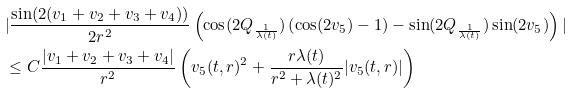<formula> <loc_0><loc_0><loc_500><loc_500>& | \frac { \sin ( 2 ( v _ { 1 } + v _ { 2 } + v _ { 3 } + v _ { 4 } ) ) } { 2 r ^ { 2 } } \left ( \cos ( 2 Q _ { \frac { 1 } { \lambda ( t ) } } ) \left ( \cos ( 2 v _ { 5 } ) - 1 \right ) - \sin ( 2 Q _ { \frac { 1 } { \lambda ( t ) } } ) \sin ( 2 v _ { 5 } ) \right ) | \\ & \leq C \frac { | v _ { 1 } + v _ { 2 } + v _ { 3 } + v _ { 4 } | } { r ^ { 2 } } \left ( v _ { 5 } ( t , r ) ^ { 2 } + \frac { r \lambda ( t ) } { r ^ { 2 } + \lambda ( t ) ^ { 2 } } | v _ { 5 } ( t , r ) | \right )</formula> 